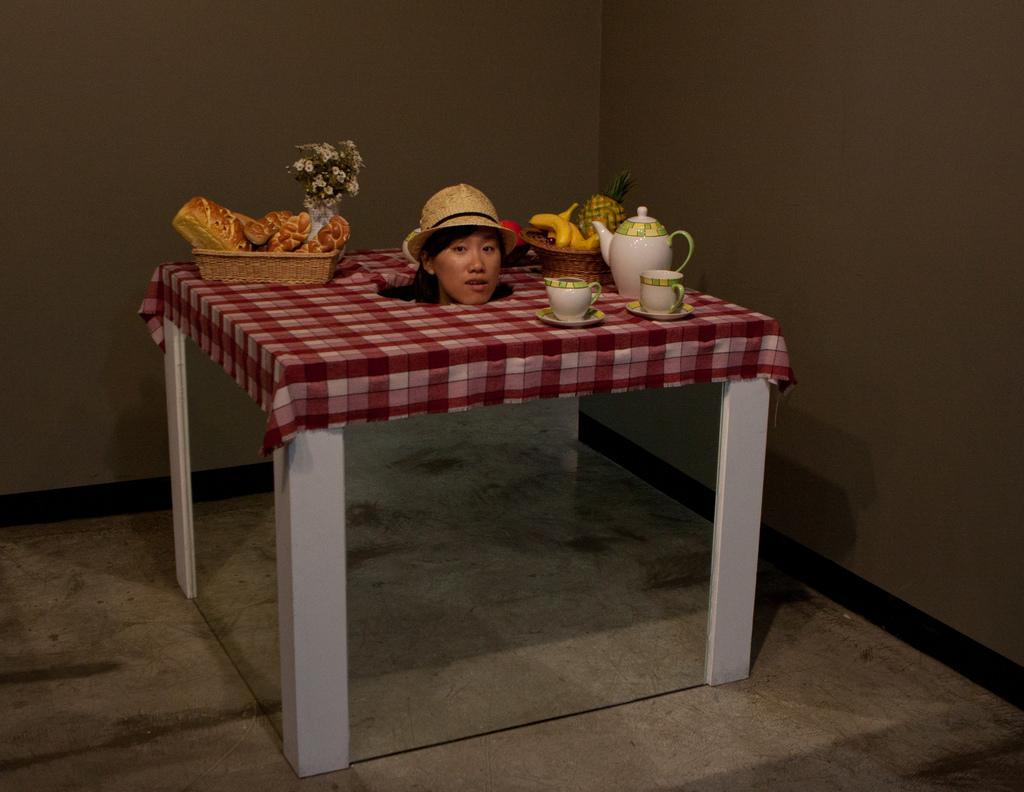In one or two sentences, can you explain what this image depicts? In this image we can see a table on which we can see table cloth, basket with food items, flower vase, cups, saucers, kettle, basket with fruits and a woman face with hat on head. Here we can see the mirrors, floor and the wall in the background. 